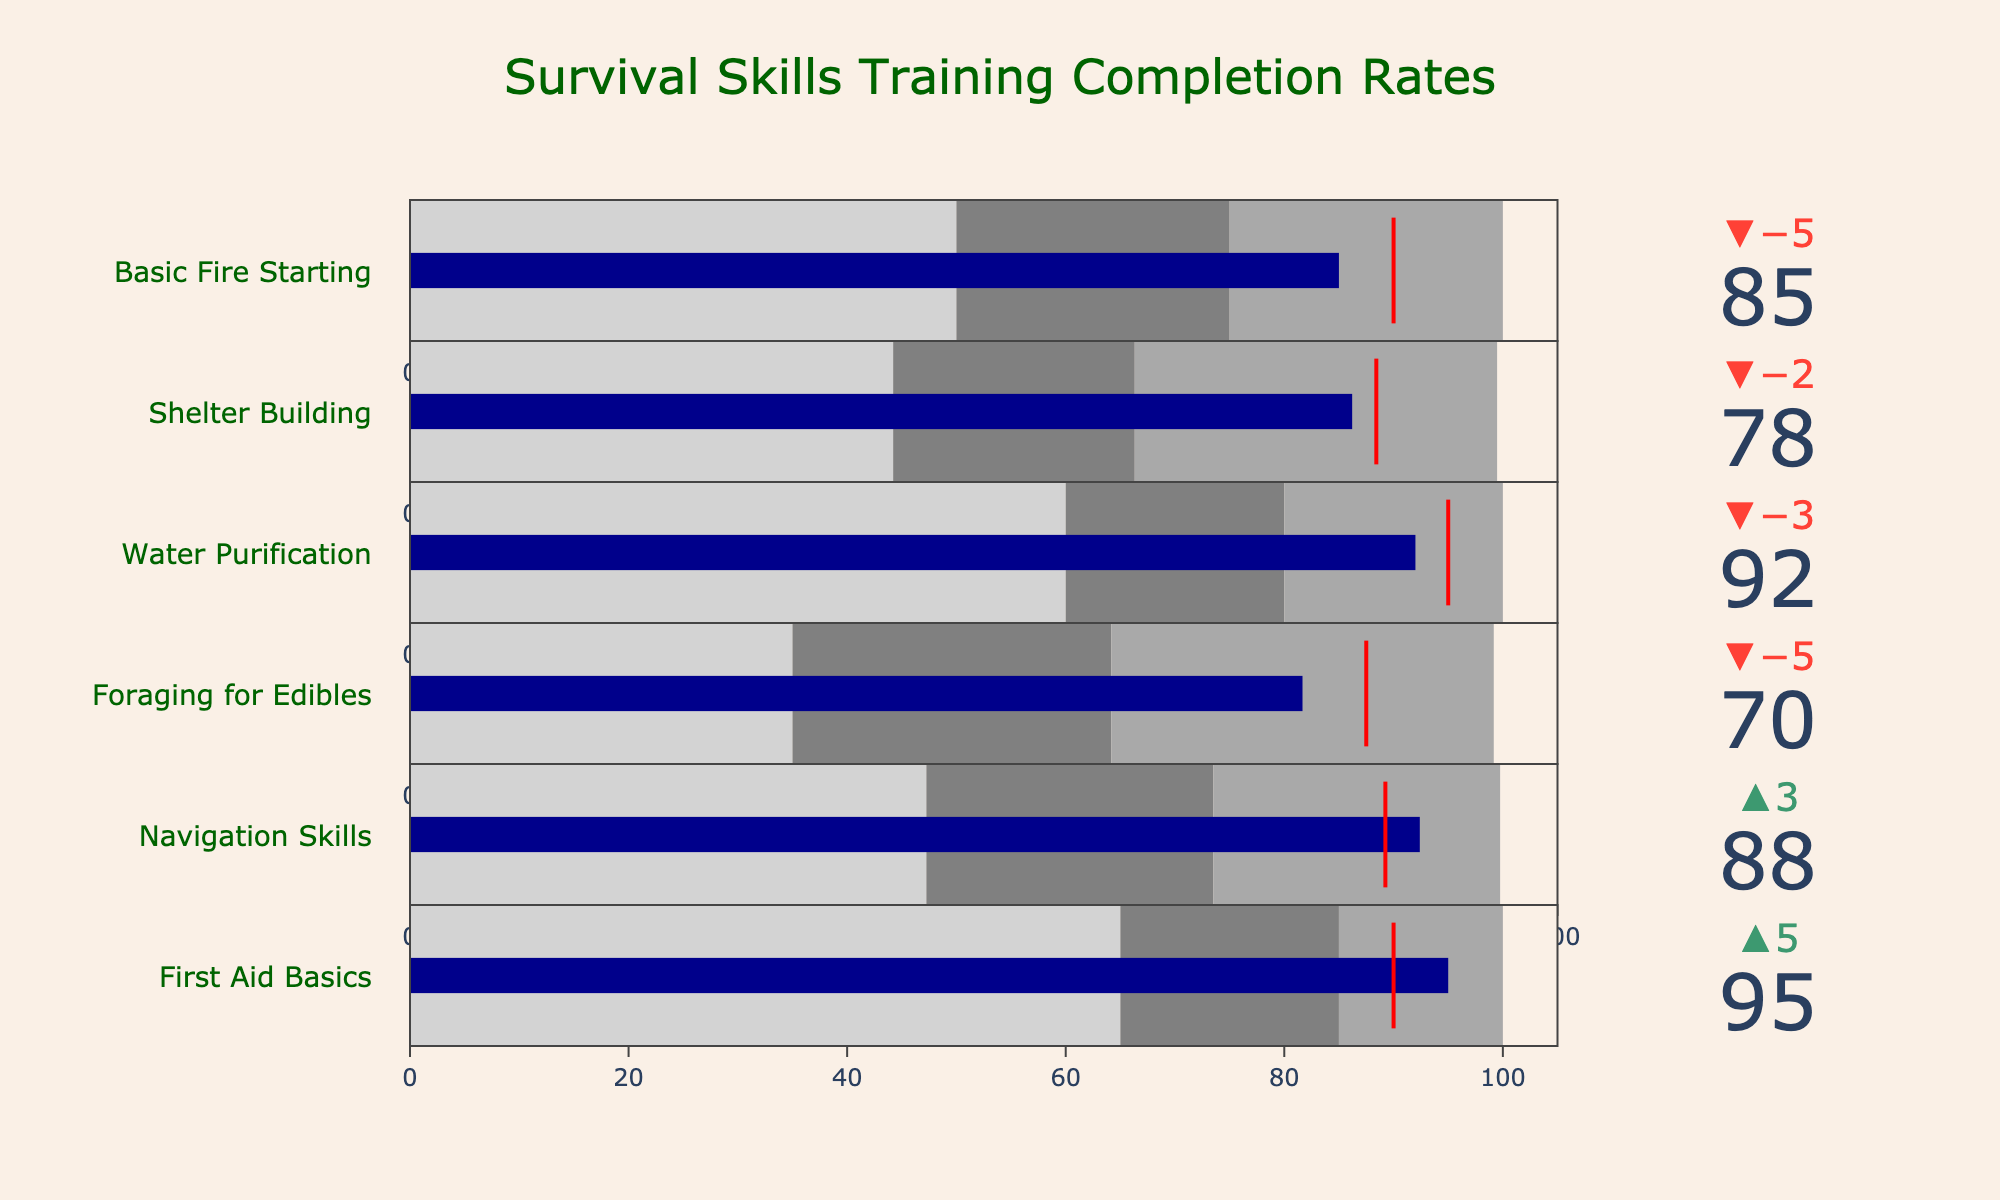What's the title of the chart? The title is located at the top center of the chart and is clearly labeled. It summarizes what the chart is about.
Answer: Survival Skills Training Completion Rates How many survival skills training courses are depicted in the chart? The chart has one indicator for each survival skill. Count the number of different titles corresponding to each skill.
Answer: Six What color represents the bar indicating the actual completion rate in each bullet chart? Look for the bar within each bullet chart that shows the actual completion rate. The color is consistently the same for all the skills.
Answer: Dark blue What is the completion rate for Basic Fire Starting? Locate the bullet chart for Basic Fire Starting and find the numeric value displayed within that particular chart.
Answer: 85 Which skill has the highest actual completion rate? Examine the actual completion rate for each skill and compare them to determine which is the highest.
Answer: First Aid Basics What is the difference between the target and actual completion rate for Foraging for Edibles? Identify the target and actual completion rates for Foraging for Edibles and subtract the actual from the target.
Answer: 5 Which skills met or exceeded their target completion rates? Compare the actual completion rate to the target rate for each skill and list those where the actual rate is equal to or higher than the target.
Answer: Navigation Skills, First Aid Basics What’s the average target completion rate across all skills? Sum the target rates for all skills and divide by the total number of skills (6). The target rates are 90, 80, 95, 75, 85, 90.
Answer: (90 + 80 + 95 + 75 + 85 + 90) / 6 = 86.67 Which skill has the lowest satisfactory threshold? Examine the satisfactory thresholds for all skills and identify the lowest value.
Answer: Foraging for Edibles How much higher is the actual completion rate of Water Purification compared to Shelter Building? Subtract the actual completion rate of Shelter Building from the actual completion rate of Water Purification.
Answer: 92 - 78 = 14 